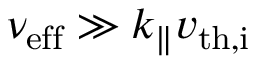<formula> <loc_0><loc_0><loc_500><loc_500>\nu _ { e f f } \gg k _ { \| } v _ { t h , i }</formula> 